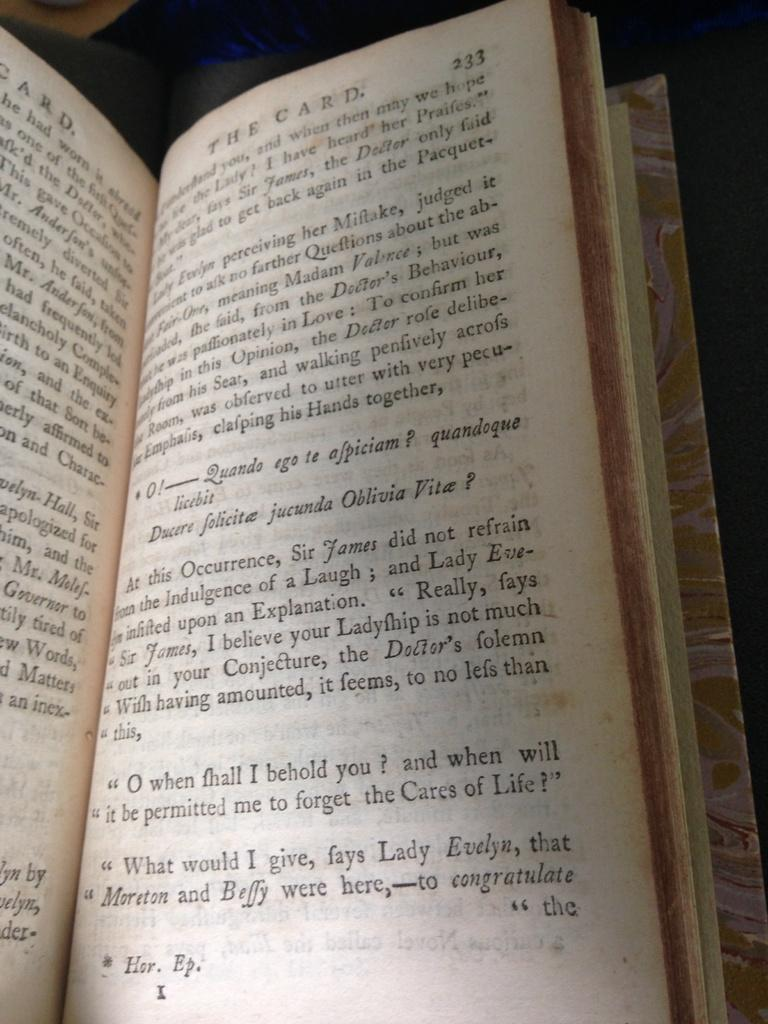<image>
Write a terse but informative summary of the picture. A book is open to page 233 and sits on a wooden surface. 